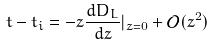Convert formula to latex. <formula><loc_0><loc_0><loc_500><loc_500>t - t _ { i } = - z \frac { d D _ { L } } { d z } | _ { z = 0 } + \mathcal { O } ( z ^ { 2 } )</formula> 